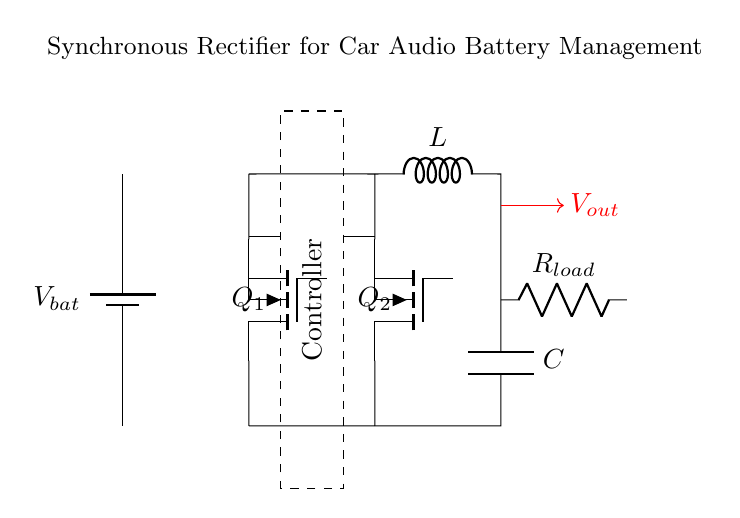What type of transistors are used in the circuit? The transistors are labeled as Q1 and Q2, which are both Tnigfete, indicating that they are n-channel MOSFETs.
Answer: Tnigfete What is the role of the controller in this circuit? The controller (shown as a dashed rectangle with a label) is responsible for driving the gate of the transistors to switch them on and off appropriately.
Answer: Drive the gates What component is used to limit current in the output? The resistor R_load is connected in series with the load and serves to limit the current flowing to it.
Answer: Resistor How many inductors are present in the circuit? There is only one inductor in the diagram, labeled as L, which is used for filtering or energy storage.
Answer: One How does the synchronous rectifier improve efficiency compared to a standard rectifier? Synchronous rectifiers use active devices like MOSFETs instead of diodes, which reduces conduction losses, leading to improved efficiency in power conversion.
Answer: Reduced conduction losses What is the output voltage indicated in the circuit? The output voltage is marked by the red arrow from the node connected to the capacitor and load and is labeled as V_out.
Answer: V_out Where does the battery voltage connect in the circuit? The battery voltage, represented as V_bat, is connected at the top of the circuit, providing power to the synchronous rectifier.
Answer: Top of the circuit 